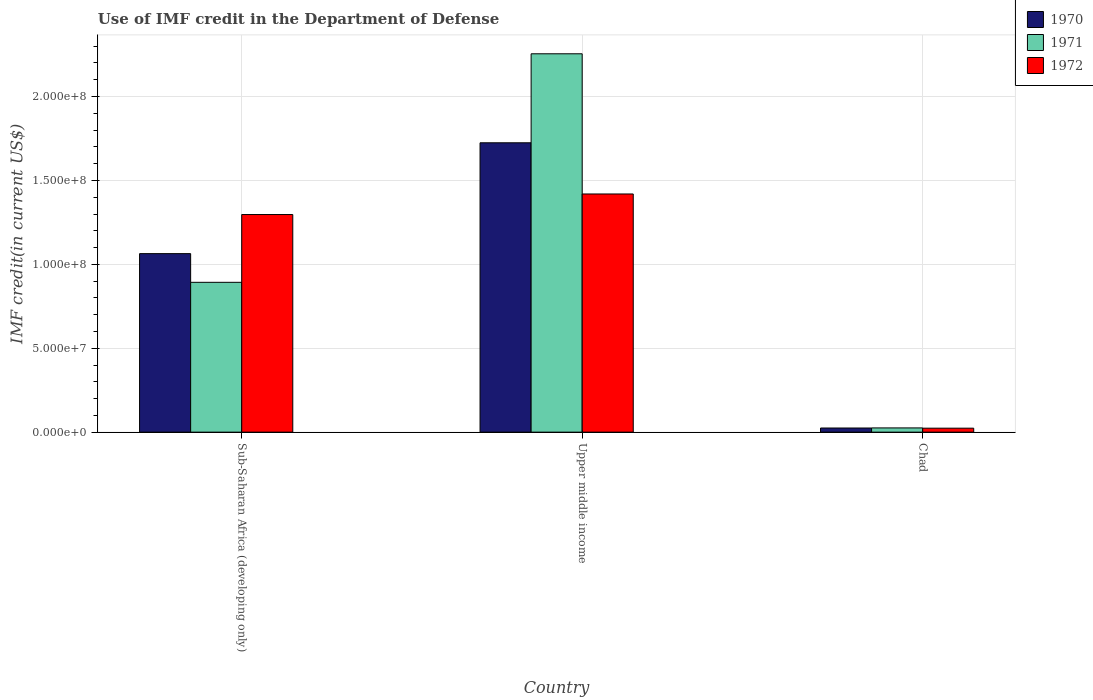How many groups of bars are there?
Give a very brief answer. 3. Are the number of bars per tick equal to the number of legend labels?
Keep it short and to the point. Yes. Are the number of bars on each tick of the X-axis equal?
Your response must be concise. Yes. What is the label of the 1st group of bars from the left?
Make the answer very short. Sub-Saharan Africa (developing only). In how many cases, is the number of bars for a given country not equal to the number of legend labels?
Your response must be concise. 0. What is the IMF credit in the Department of Defense in 1971 in Chad?
Make the answer very short. 2.52e+06. Across all countries, what is the maximum IMF credit in the Department of Defense in 1972?
Your answer should be very brief. 1.42e+08. Across all countries, what is the minimum IMF credit in the Department of Defense in 1971?
Your answer should be very brief. 2.52e+06. In which country was the IMF credit in the Department of Defense in 1972 maximum?
Provide a succinct answer. Upper middle income. In which country was the IMF credit in the Department of Defense in 1972 minimum?
Provide a short and direct response. Chad. What is the total IMF credit in the Department of Defense in 1970 in the graph?
Give a very brief answer. 2.81e+08. What is the difference between the IMF credit in the Department of Defense in 1970 in Chad and that in Sub-Saharan Africa (developing only)?
Offer a terse response. -1.04e+08. What is the difference between the IMF credit in the Department of Defense in 1970 in Sub-Saharan Africa (developing only) and the IMF credit in the Department of Defense in 1971 in Chad?
Provide a short and direct response. 1.04e+08. What is the average IMF credit in the Department of Defense in 1970 per country?
Provide a short and direct response. 9.38e+07. What is the difference between the IMF credit in the Department of Defense of/in 1971 and IMF credit in the Department of Defense of/in 1972 in Sub-Saharan Africa (developing only)?
Keep it short and to the point. -4.04e+07. In how many countries, is the IMF credit in the Department of Defense in 1970 greater than 40000000 US$?
Your response must be concise. 2. What is the ratio of the IMF credit in the Department of Defense in 1971 in Sub-Saharan Africa (developing only) to that in Upper middle income?
Your answer should be compact. 0.4. Is the IMF credit in the Department of Defense in 1970 in Sub-Saharan Africa (developing only) less than that in Upper middle income?
Make the answer very short. Yes. Is the difference between the IMF credit in the Department of Defense in 1971 in Chad and Sub-Saharan Africa (developing only) greater than the difference between the IMF credit in the Department of Defense in 1972 in Chad and Sub-Saharan Africa (developing only)?
Your answer should be very brief. Yes. What is the difference between the highest and the second highest IMF credit in the Department of Defense in 1972?
Ensure brevity in your answer.  1.40e+08. What is the difference between the highest and the lowest IMF credit in the Department of Defense in 1971?
Ensure brevity in your answer.  2.23e+08. In how many countries, is the IMF credit in the Department of Defense in 1971 greater than the average IMF credit in the Department of Defense in 1971 taken over all countries?
Offer a very short reply. 1. Is the sum of the IMF credit in the Department of Defense in 1972 in Sub-Saharan Africa (developing only) and Upper middle income greater than the maximum IMF credit in the Department of Defense in 1971 across all countries?
Offer a very short reply. Yes. What does the 1st bar from the left in Upper middle income represents?
Your answer should be compact. 1970. How many bars are there?
Provide a succinct answer. 9. Are all the bars in the graph horizontal?
Provide a succinct answer. No. What is the difference between two consecutive major ticks on the Y-axis?
Your answer should be compact. 5.00e+07. Does the graph contain any zero values?
Give a very brief answer. No. Where does the legend appear in the graph?
Provide a short and direct response. Top right. How many legend labels are there?
Your answer should be compact. 3. What is the title of the graph?
Provide a short and direct response. Use of IMF credit in the Department of Defense. What is the label or title of the X-axis?
Provide a short and direct response. Country. What is the label or title of the Y-axis?
Give a very brief answer. IMF credit(in current US$). What is the IMF credit(in current US$) in 1970 in Sub-Saharan Africa (developing only)?
Provide a short and direct response. 1.06e+08. What is the IMF credit(in current US$) in 1971 in Sub-Saharan Africa (developing only)?
Offer a very short reply. 8.93e+07. What is the IMF credit(in current US$) of 1972 in Sub-Saharan Africa (developing only)?
Make the answer very short. 1.30e+08. What is the IMF credit(in current US$) in 1970 in Upper middle income?
Your response must be concise. 1.72e+08. What is the IMF credit(in current US$) of 1971 in Upper middle income?
Your response must be concise. 2.25e+08. What is the IMF credit(in current US$) in 1972 in Upper middle income?
Make the answer very short. 1.42e+08. What is the IMF credit(in current US$) of 1970 in Chad?
Provide a short and direct response. 2.47e+06. What is the IMF credit(in current US$) in 1971 in Chad?
Offer a very short reply. 2.52e+06. What is the IMF credit(in current US$) in 1972 in Chad?
Give a very brief answer. 2.37e+06. Across all countries, what is the maximum IMF credit(in current US$) of 1970?
Make the answer very short. 1.72e+08. Across all countries, what is the maximum IMF credit(in current US$) of 1971?
Make the answer very short. 2.25e+08. Across all countries, what is the maximum IMF credit(in current US$) in 1972?
Your response must be concise. 1.42e+08. Across all countries, what is the minimum IMF credit(in current US$) in 1970?
Your answer should be compact. 2.47e+06. Across all countries, what is the minimum IMF credit(in current US$) in 1971?
Make the answer very short. 2.52e+06. Across all countries, what is the minimum IMF credit(in current US$) of 1972?
Your answer should be very brief. 2.37e+06. What is the total IMF credit(in current US$) in 1970 in the graph?
Give a very brief answer. 2.81e+08. What is the total IMF credit(in current US$) of 1971 in the graph?
Provide a succinct answer. 3.17e+08. What is the total IMF credit(in current US$) of 1972 in the graph?
Your answer should be very brief. 2.74e+08. What is the difference between the IMF credit(in current US$) in 1970 in Sub-Saharan Africa (developing only) and that in Upper middle income?
Give a very brief answer. -6.61e+07. What is the difference between the IMF credit(in current US$) in 1971 in Sub-Saharan Africa (developing only) and that in Upper middle income?
Offer a very short reply. -1.36e+08. What is the difference between the IMF credit(in current US$) in 1972 in Sub-Saharan Africa (developing only) and that in Upper middle income?
Keep it short and to the point. -1.23e+07. What is the difference between the IMF credit(in current US$) of 1970 in Sub-Saharan Africa (developing only) and that in Chad?
Provide a short and direct response. 1.04e+08. What is the difference between the IMF credit(in current US$) of 1971 in Sub-Saharan Africa (developing only) and that in Chad?
Ensure brevity in your answer.  8.68e+07. What is the difference between the IMF credit(in current US$) of 1972 in Sub-Saharan Africa (developing only) and that in Chad?
Make the answer very short. 1.27e+08. What is the difference between the IMF credit(in current US$) of 1970 in Upper middle income and that in Chad?
Your answer should be very brief. 1.70e+08. What is the difference between the IMF credit(in current US$) of 1971 in Upper middle income and that in Chad?
Offer a very short reply. 2.23e+08. What is the difference between the IMF credit(in current US$) in 1972 in Upper middle income and that in Chad?
Provide a succinct answer. 1.40e+08. What is the difference between the IMF credit(in current US$) of 1970 in Sub-Saharan Africa (developing only) and the IMF credit(in current US$) of 1971 in Upper middle income?
Provide a short and direct response. -1.19e+08. What is the difference between the IMF credit(in current US$) of 1970 in Sub-Saharan Africa (developing only) and the IMF credit(in current US$) of 1972 in Upper middle income?
Give a very brief answer. -3.56e+07. What is the difference between the IMF credit(in current US$) of 1971 in Sub-Saharan Africa (developing only) and the IMF credit(in current US$) of 1972 in Upper middle income?
Give a very brief answer. -5.27e+07. What is the difference between the IMF credit(in current US$) in 1970 in Sub-Saharan Africa (developing only) and the IMF credit(in current US$) in 1971 in Chad?
Your answer should be very brief. 1.04e+08. What is the difference between the IMF credit(in current US$) in 1970 in Sub-Saharan Africa (developing only) and the IMF credit(in current US$) in 1972 in Chad?
Provide a succinct answer. 1.04e+08. What is the difference between the IMF credit(in current US$) of 1971 in Sub-Saharan Africa (developing only) and the IMF credit(in current US$) of 1972 in Chad?
Your answer should be very brief. 8.69e+07. What is the difference between the IMF credit(in current US$) of 1970 in Upper middle income and the IMF credit(in current US$) of 1971 in Chad?
Ensure brevity in your answer.  1.70e+08. What is the difference between the IMF credit(in current US$) of 1970 in Upper middle income and the IMF credit(in current US$) of 1972 in Chad?
Give a very brief answer. 1.70e+08. What is the difference between the IMF credit(in current US$) of 1971 in Upper middle income and the IMF credit(in current US$) of 1972 in Chad?
Give a very brief answer. 2.23e+08. What is the average IMF credit(in current US$) in 1970 per country?
Your answer should be very brief. 9.38e+07. What is the average IMF credit(in current US$) in 1971 per country?
Your response must be concise. 1.06e+08. What is the average IMF credit(in current US$) of 1972 per country?
Your answer should be very brief. 9.13e+07. What is the difference between the IMF credit(in current US$) of 1970 and IMF credit(in current US$) of 1971 in Sub-Saharan Africa (developing only)?
Make the answer very short. 1.71e+07. What is the difference between the IMF credit(in current US$) in 1970 and IMF credit(in current US$) in 1972 in Sub-Saharan Africa (developing only)?
Your response must be concise. -2.33e+07. What is the difference between the IMF credit(in current US$) of 1971 and IMF credit(in current US$) of 1972 in Sub-Saharan Africa (developing only)?
Keep it short and to the point. -4.04e+07. What is the difference between the IMF credit(in current US$) in 1970 and IMF credit(in current US$) in 1971 in Upper middle income?
Provide a short and direct response. -5.30e+07. What is the difference between the IMF credit(in current US$) in 1970 and IMF credit(in current US$) in 1972 in Upper middle income?
Ensure brevity in your answer.  3.05e+07. What is the difference between the IMF credit(in current US$) of 1971 and IMF credit(in current US$) of 1972 in Upper middle income?
Offer a very short reply. 8.35e+07. What is the difference between the IMF credit(in current US$) of 1970 and IMF credit(in current US$) of 1971 in Chad?
Offer a very short reply. -4.90e+04. What is the difference between the IMF credit(in current US$) of 1970 and IMF credit(in current US$) of 1972 in Chad?
Make the answer very short. 1.03e+05. What is the difference between the IMF credit(in current US$) of 1971 and IMF credit(in current US$) of 1972 in Chad?
Your answer should be compact. 1.52e+05. What is the ratio of the IMF credit(in current US$) of 1970 in Sub-Saharan Africa (developing only) to that in Upper middle income?
Offer a terse response. 0.62. What is the ratio of the IMF credit(in current US$) of 1971 in Sub-Saharan Africa (developing only) to that in Upper middle income?
Offer a terse response. 0.4. What is the ratio of the IMF credit(in current US$) of 1972 in Sub-Saharan Africa (developing only) to that in Upper middle income?
Offer a terse response. 0.91. What is the ratio of the IMF credit(in current US$) in 1970 in Sub-Saharan Africa (developing only) to that in Chad?
Your answer should be compact. 43.07. What is the ratio of the IMF credit(in current US$) of 1971 in Sub-Saharan Africa (developing only) to that in Chad?
Provide a succinct answer. 35.45. What is the ratio of the IMF credit(in current US$) of 1972 in Sub-Saharan Africa (developing only) to that in Chad?
Offer a terse response. 54.79. What is the ratio of the IMF credit(in current US$) of 1970 in Upper middle income to that in Chad?
Offer a very short reply. 69.82. What is the ratio of the IMF credit(in current US$) in 1971 in Upper middle income to that in Chad?
Keep it short and to the point. 89.51. What is the ratio of the IMF credit(in current US$) in 1972 in Upper middle income to that in Chad?
Give a very brief answer. 59.97. What is the difference between the highest and the second highest IMF credit(in current US$) of 1970?
Offer a terse response. 6.61e+07. What is the difference between the highest and the second highest IMF credit(in current US$) in 1971?
Your answer should be compact. 1.36e+08. What is the difference between the highest and the second highest IMF credit(in current US$) of 1972?
Your response must be concise. 1.23e+07. What is the difference between the highest and the lowest IMF credit(in current US$) of 1970?
Ensure brevity in your answer.  1.70e+08. What is the difference between the highest and the lowest IMF credit(in current US$) of 1971?
Your response must be concise. 2.23e+08. What is the difference between the highest and the lowest IMF credit(in current US$) of 1972?
Your answer should be compact. 1.40e+08. 